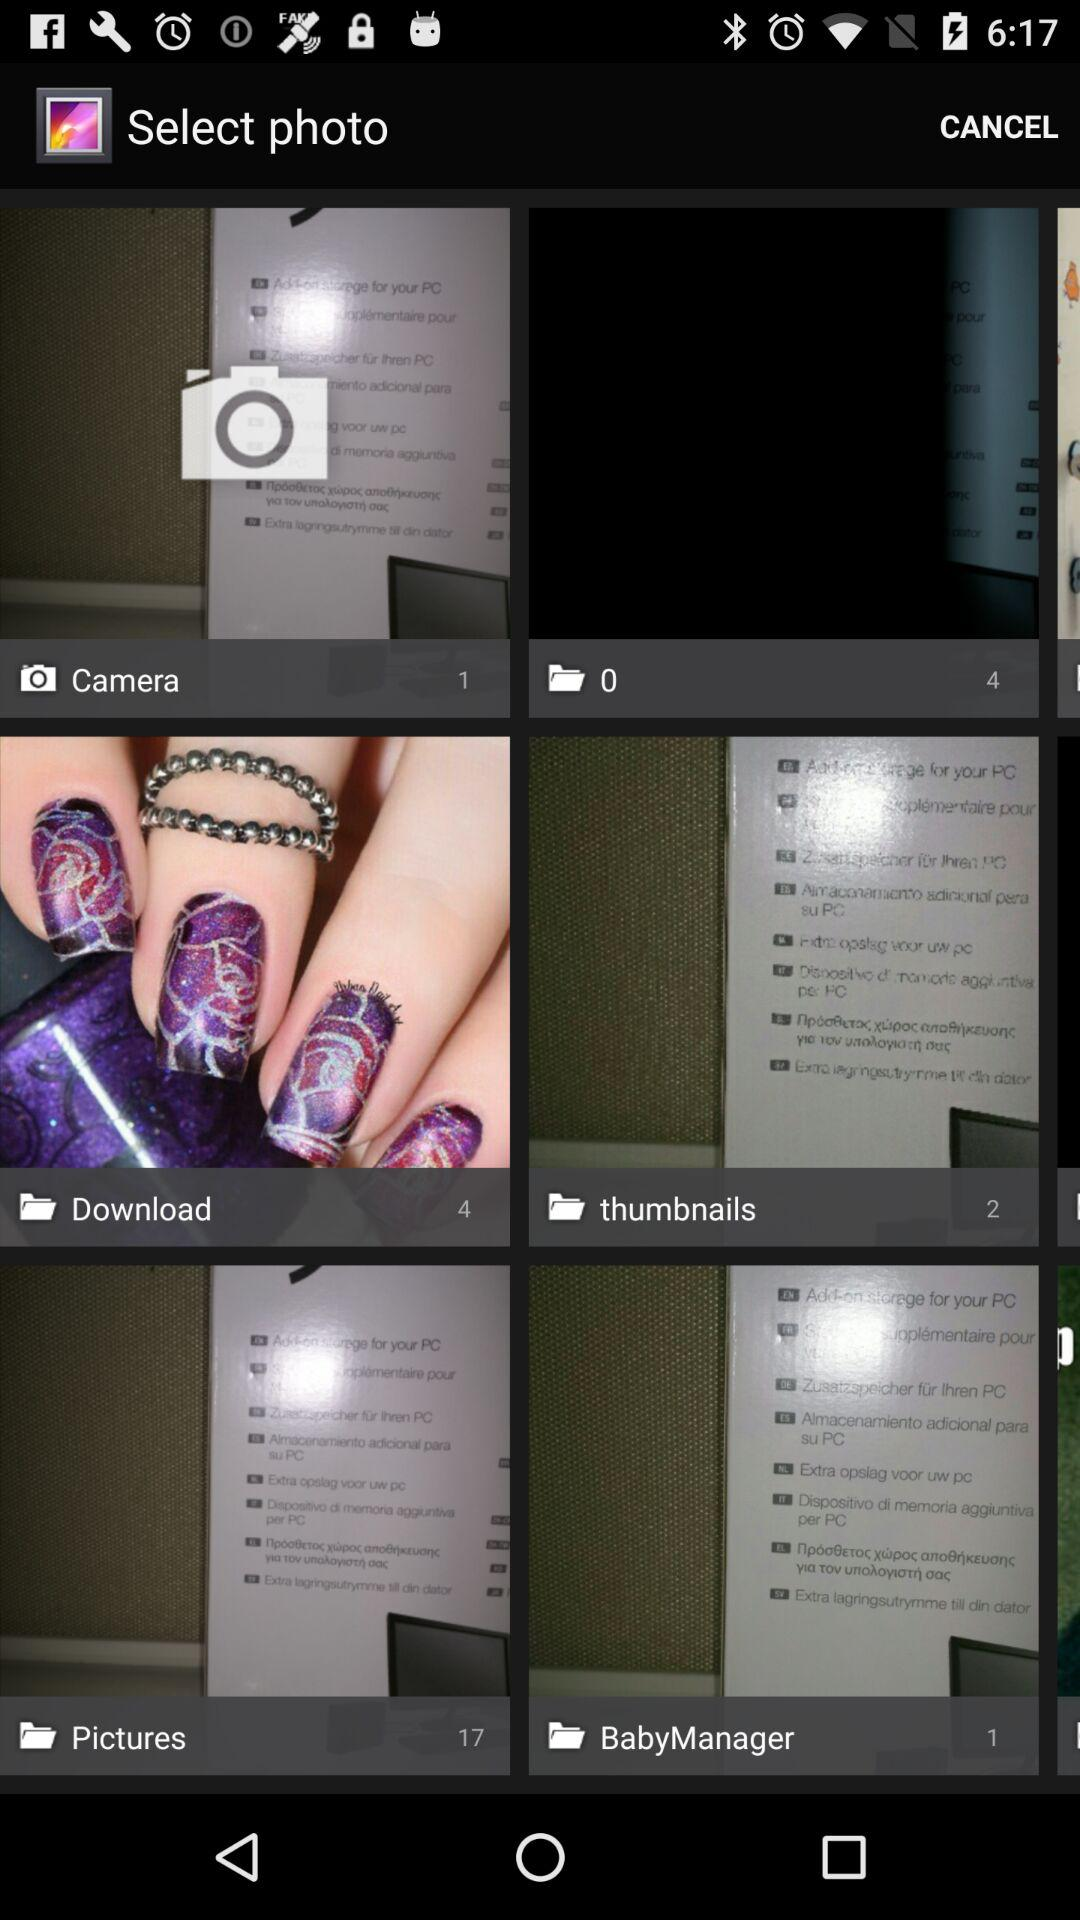Which photo was selected?
When the provided information is insufficient, respond with <no answer>. <no answer> 